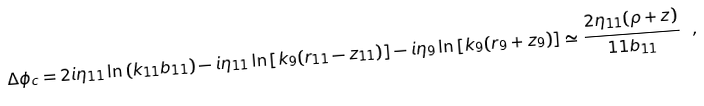Convert formula to latex. <formula><loc_0><loc_0><loc_500><loc_500>\Delta \phi _ { c } = 2 i \eta _ { 1 1 } \ln \left ( k _ { 1 1 } b _ { 1 1 } \right ) - i \eta _ { 1 1 } \ln \left [ k _ { 9 } ( r _ { 1 1 } - z _ { 1 1 } ) \right ] - i \eta _ { 9 } \ln \left [ k _ { 9 } ( r _ { 9 } + z _ { 9 } ) \right ] \simeq { \frac { 2 \eta _ { 1 1 } ( \rho + z ) } { 1 1 b _ { 1 1 } } } \ ,</formula> 